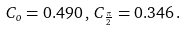Convert formula to latex. <formula><loc_0><loc_0><loc_500><loc_500>C _ { o } = 0 . 4 9 0 \, , \, C _ { \frac { \pi } { 2 } } = 0 . 3 4 6 \, .</formula> 